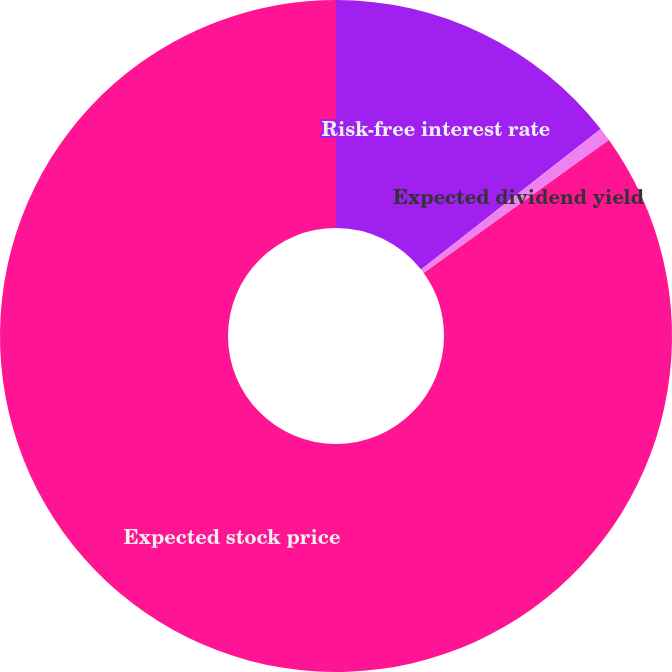<chart> <loc_0><loc_0><loc_500><loc_500><pie_chart><fcel>Risk-free interest rate<fcel>Expected dividend yield<fcel>Expected stock price<nl><fcel>14.44%<fcel>0.65%<fcel>84.92%<nl></chart> 